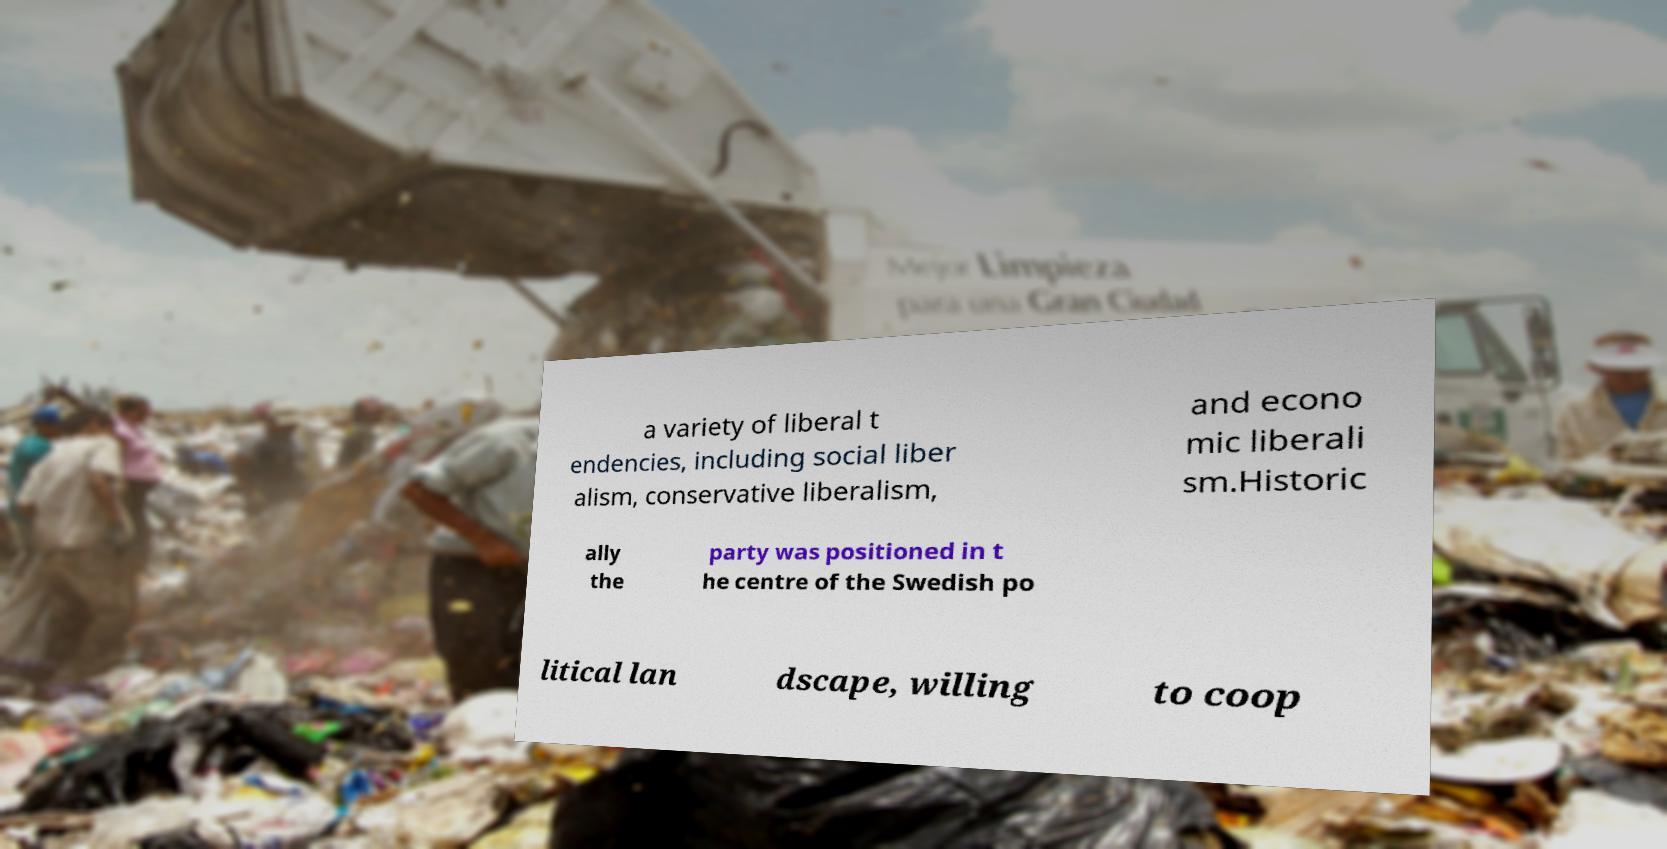There's text embedded in this image that I need extracted. Can you transcribe it verbatim? a variety of liberal t endencies, including social liber alism, conservative liberalism, and econo mic liberali sm.Historic ally the party was positioned in t he centre of the Swedish po litical lan dscape, willing to coop 